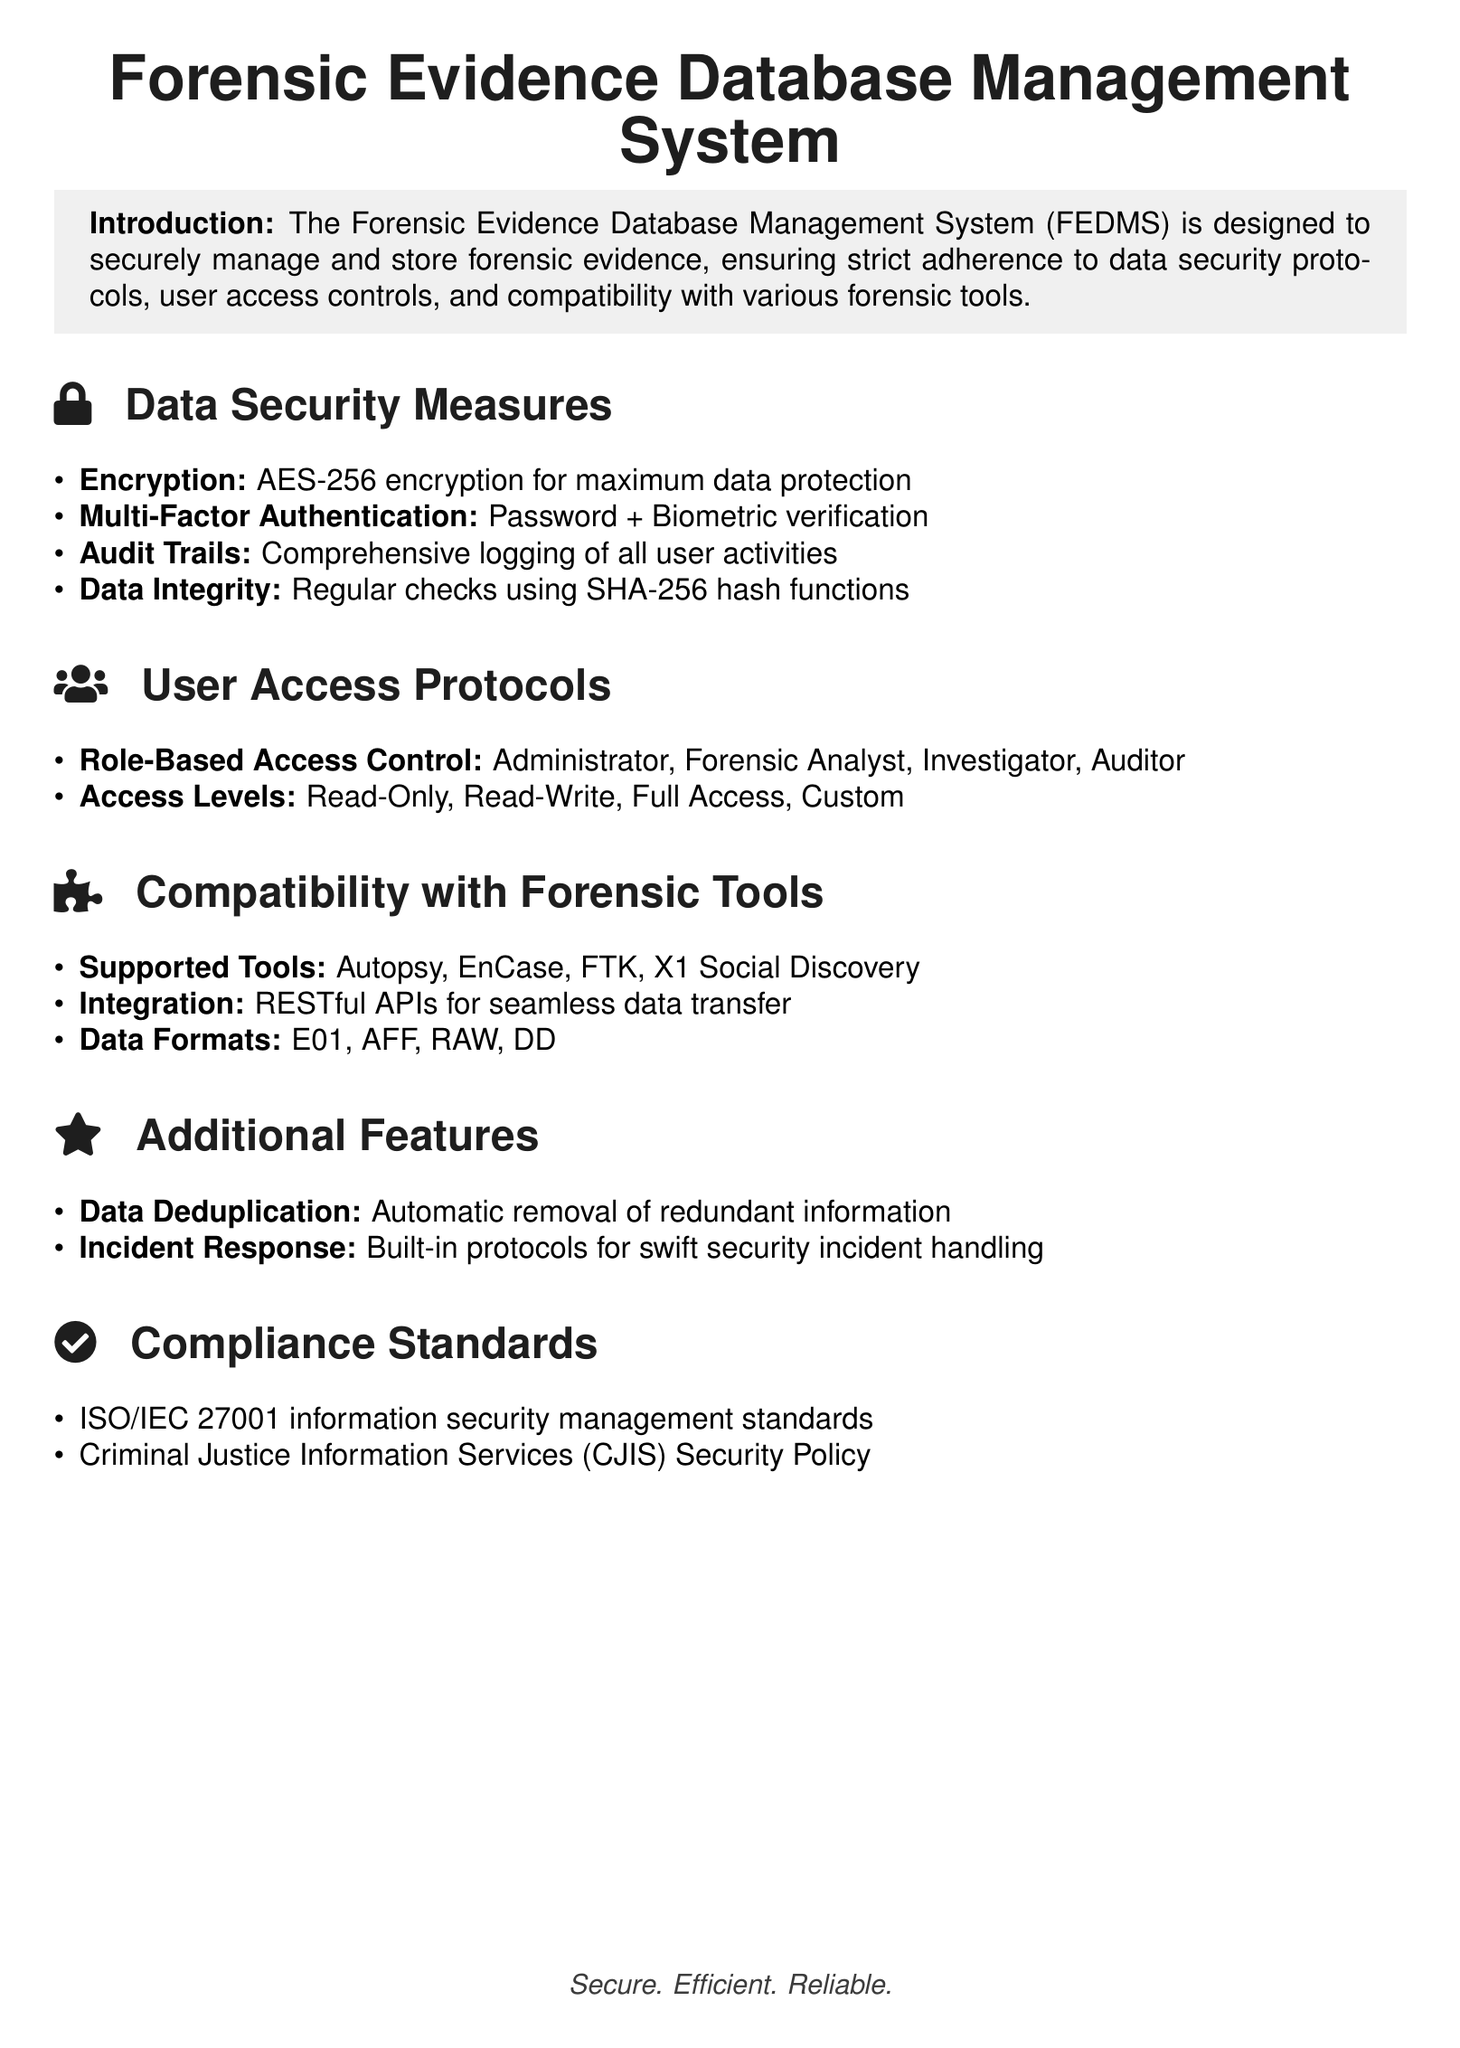What encryption standard is used? The document specifies the encryption standard used for data protection, which is AES-256.
Answer: AES-256 What type of authentication is required? The document mentions the combination of different types of authentication for accessing the system, which includes password and biometric verification.
Answer: Password + Biometric verification How many user roles are defined? The document lists the different user roles under user access protocols, which includes four distinct roles.
Answer: Four What is the primary data integrity method mentioned? The document states that regular checks using a specific hash function are used to maintain data integrity, which is SHA-256.
Answer: SHA-256 Which forensic tools are supported? The document lists the supported forensic tools, among which Autopsy is one of them.
Answer: Autopsy What type of APIs facilitate integration? The document highlights that RESTful APIs are used for seamless data transfer with various forensic tools.
Answer: RESTful APIs What is the compliance standard mentioned for information security? The document specifies ISO/IEC 27001 as one of the compliance standards for information security management.
Answer: ISO/IEC 27001 What feature aids in optimizing data storage? The document mentions a specific feature that automatically removes redundant information to optimize data storage.
Answer: Data Deduplication 